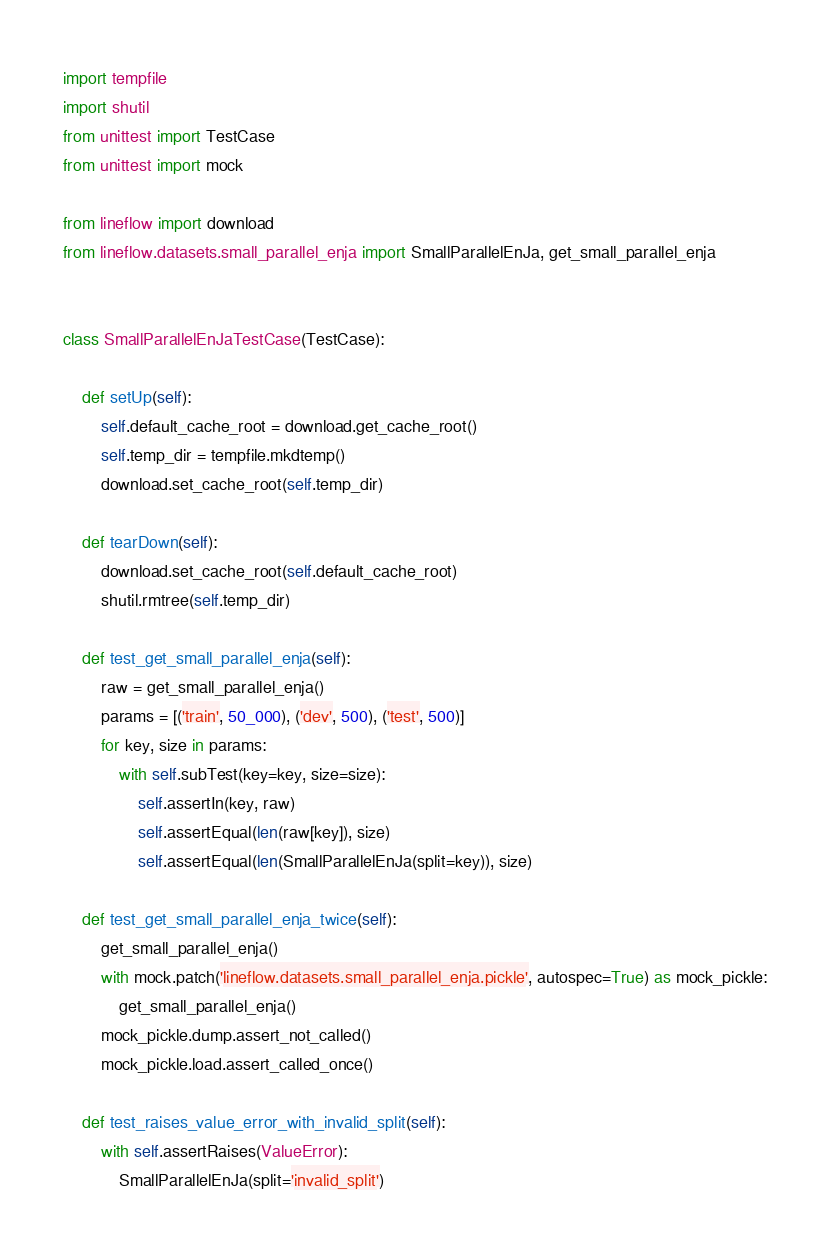Convert code to text. <code><loc_0><loc_0><loc_500><loc_500><_Python_>import tempfile
import shutil
from unittest import TestCase
from unittest import mock

from lineflow import download
from lineflow.datasets.small_parallel_enja import SmallParallelEnJa, get_small_parallel_enja


class SmallParallelEnJaTestCase(TestCase):

    def setUp(self):
        self.default_cache_root = download.get_cache_root()
        self.temp_dir = tempfile.mkdtemp()
        download.set_cache_root(self.temp_dir)

    def tearDown(self):
        download.set_cache_root(self.default_cache_root)
        shutil.rmtree(self.temp_dir)

    def test_get_small_parallel_enja(self):
        raw = get_small_parallel_enja()
        params = [('train', 50_000), ('dev', 500), ('test', 500)]
        for key, size in params:
            with self.subTest(key=key, size=size):
                self.assertIn(key, raw)
                self.assertEqual(len(raw[key]), size)
                self.assertEqual(len(SmallParallelEnJa(split=key)), size)

    def test_get_small_parallel_enja_twice(self):
        get_small_parallel_enja()
        with mock.patch('lineflow.datasets.small_parallel_enja.pickle', autospec=True) as mock_pickle:
            get_small_parallel_enja()
        mock_pickle.dump.assert_not_called()
        mock_pickle.load.assert_called_once()

    def test_raises_value_error_with_invalid_split(self):
        with self.assertRaises(ValueError):
            SmallParallelEnJa(split='invalid_split')
</code> 